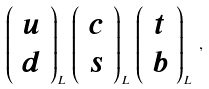<formula> <loc_0><loc_0><loc_500><loc_500>\left ( \begin{array} { c } u \\ d \end{array} \right ) _ { L } \, \left ( \begin{array} { c } c \\ s \end{array} \right ) _ { L } \, \left ( \begin{array} { c } t \\ b \end{array} \right ) _ { L } \, ,</formula> 